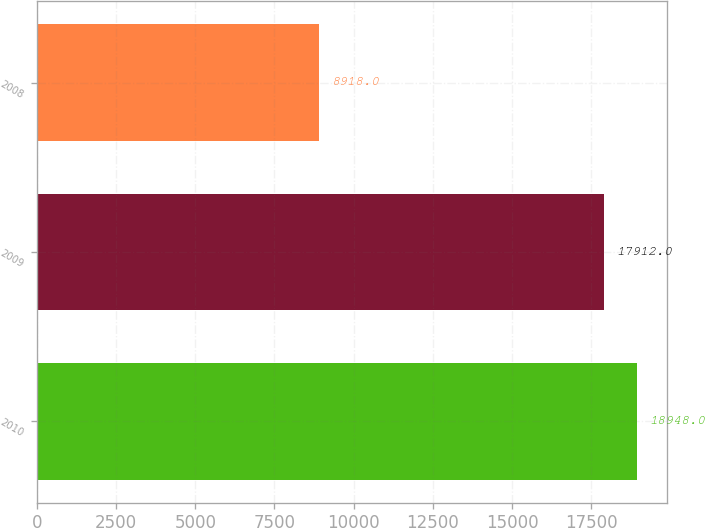<chart> <loc_0><loc_0><loc_500><loc_500><bar_chart><fcel>2010<fcel>2009<fcel>2008<nl><fcel>18948<fcel>17912<fcel>8918<nl></chart> 